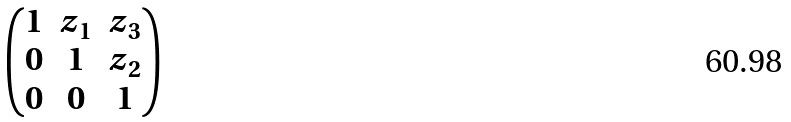Convert formula to latex. <formula><loc_0><loc_0><loc_500><loc_500>\begin{pmatrix} 1 & z _ { 1 } & z _ { 3 } \\ 0 & 1 & z _ { 2 } \\ 0 & 0 & 1 \end{pmatrix}</formula> 